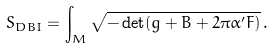<formula> <loc_0><loc_0><loc_500><loc_500>S _ { D B I } = \int _ { M } \sqrt { - \det ( g + B + 2 \pi \alpha ^ { \prime } F ) } \, .</formula> 